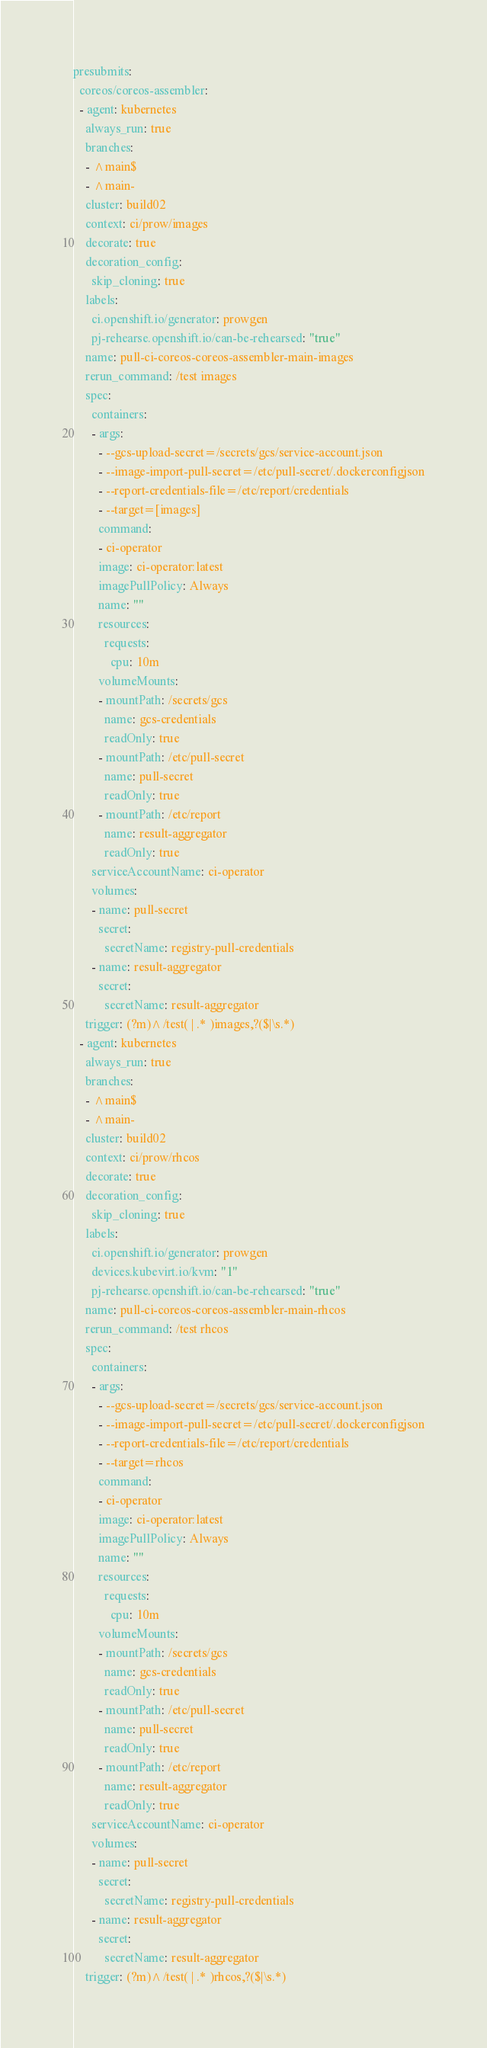Convert code to text. <code><loc_0><loc_0><loc_500><loc_500><_YAML_>presubmits:
  coreos/coreos-assembler:
  - agent: kubernetes
    always_run: true
    branches:
    - ^main$
    - ^main-
    cluster: build02
    context: ci/prow/images
    decorate: true
    decoration_config:
      skip_cloning: true
    labels:
      ci.openshift.io/generator: prowgen
      pj-rehearse.openshift.io/can-be-rehearsed: "true"
    name: pull-ci-coreos-coreos-assembler-main-images
    rerun_command: /test images
    spec:
      containers:
      - args:
        - --gcs-upload-secret=/secrets/gcs/service-account.json
        - --image-import-pull-secret=/etc/pull-secret/.dockerconfigjson
        - --report-credentials-file=/etc/report/credentials
        - --target=[images]
        command:
        - ci-operator
        image: ci-operator:latest
        imagePullPolicy: Always
        name: ""
        resources:
          requests:
            cpu: 10m
        volumeMounts:
        - mountPath: /secrets/gcs
          name: gcs-credentials
          readOnly: true
        - mountPath: /etc/pull-secret
          name: pull-secret
          readOnly: true
        - mountPath: /etc/report
          name: result-aggregator
          readOnly: true
      serviceAccountName: ci-operator
      volumes:
      - name: pull-secret
        secret:
          secretName: registry-pull-credentials
      - name: result-aggregator
        secret:
          secretName: result-aggregator
    trigger: (?m)^/test( | .* )images,?($|\s.*)
  - agent: kubernetes
    always_run: true
    branches:
    - ^main$
    - ^main-
    cluster: build02
    context: ci/prow/rhcos
    decorate: true
    decoration_config:
      skip_cloning: true
    labels:
      ci.openshift.io/generator: prowgen
      devices.kubevirt.io/kvm: "1"
      pj-rehearse.openshift.io/can-be-rehearsed: "true"
    name: pull-ci-coreos-coreos-assembler-main-rhcos
    rerun_command: /test rhcos
    spec:
      containers:
      - args:
        - --gcs-upload-secret=/secrets/gcs/service-account.json
        - --image-import-pull-secret=/etc/pull-secret/.dockerconfigjson
        - --report-credentials-file=/etc/report/credentials
        - --target=rhcos
        command:
        - ci-operator
        image: ci-operator:latest
        imagePullPolicy: Always
        name: ""
        resources:
          requests:
            cpu: 10m
        volumeMounts:
        - mountPath: /secrets/gcs
          name: gcs-credentials
          readOnly: true
        - mountPath: /etc/pull-secret
          name: pull-secret
          readOnly: true
        - mountPath: /etc/report
          name: result-aggregator
          readOnly: true
      serviceAccountName: ci-operator
      volumes:
      - name: pull-secret
        secret:
          secretName: registry-pull-credentials
      - name: result-aggregator
        secret:
          secretName: result-aggregator
    trigger: (?m)^/test( | .* )rhcos,?($|\s.*)
</code> 